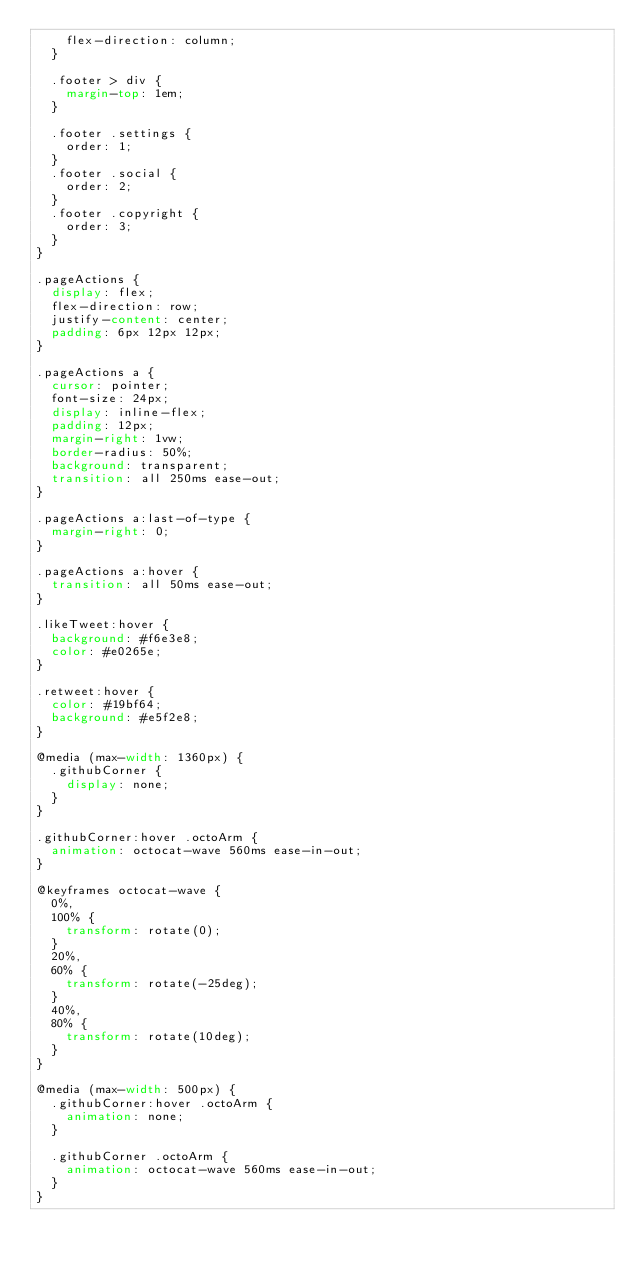<code> <loc_0><loc_0><loc_500><loc_500><_CSS_>    flex-direction: column;
  }

  .footer > div {
    margin-top: 1em;
  }

  .footer .settings {
    order: 1;
  }
  .footer .social {
    order: 2;
  }
  .footer .copyright {
    order: 3;
  }
}

.pageActions {
  display: flex;
  flex-direction: row;
  justify-content: center;
  padding: 6px 12px 12px;
}

.pageActions a {
  cursor: pointer;
  font-size: 24px;
  display: inline-flex;
  padding: 12px;
  margin-right: 1vw;
  border-radius: 50%;
  background: transparent;
  transition: all 250ms ease-out;
}

.pageActions a:last-of-type {
  margin-right: 0;
}

.pageActions a:hover {
  transition: all 50ms ease-out;
}

.likeTweet:hover {
  background: #f6e3e8;
  color: #e0265e;
}

.retweet:hover {
  color: #19bf64;
  background: #e5f2e8;
}

@media (max-width: 1360px) {
  .githubCorner {
    display: none;
  }
}

.githubCorner:hover .octoArm {
  animation: octocat-wave 560ms ease-in-out;
}

@keyframes octocat-wave {
  0%,
  100% {
    transform: rotate(0);
  }
  20%,
  60% {
    transform: rotate(-25deg);
  }
  40%,
  80% {
    transform: rotate(10deg);
  }
}

@media (max-width: 500px) {
  .githubCorner:hover .octoArm {
    animation: none;
  }

  .githubCorner .octoArm {
    animation: octocat-wave 560ms ease-in-out;
  }
}
</code> 